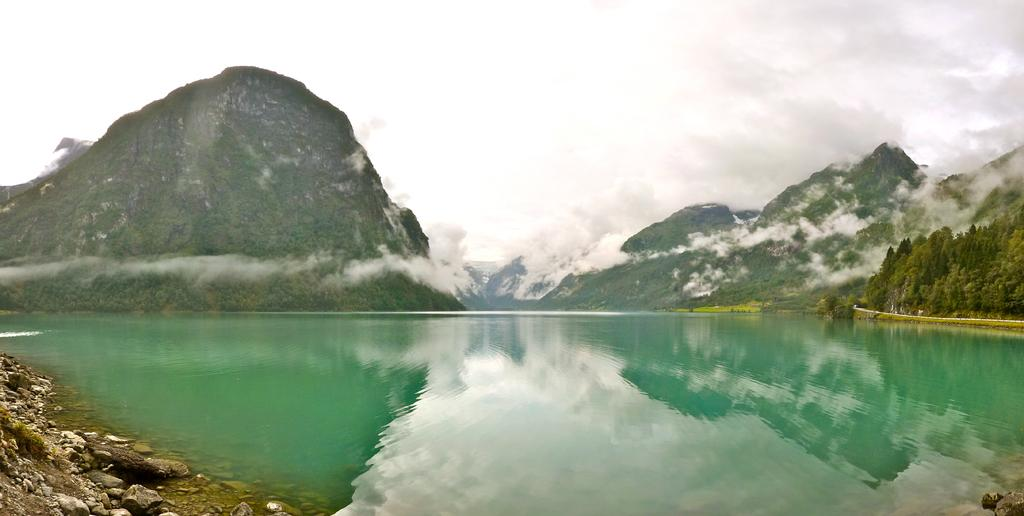What type of natural landform can be seen in the image? There are mountains in the image. What body of water is visible in the image? There is water visible in the image. What type of vegetation is present in the image? There are trees in the image. What atmospheric feature can be seen in the image? Clouds are present in the image. What type of weather condition is suggested by the presence of snow in the image? The presence of snow suggests cold weather in the image. What part of the environment is visible in the image? The sky is visible in the image. What is the name of the island in the image? There is no island present in the image; it features mountains, water, trees, clouds, and snow. How does the brake system work on the vehicle in the image? There is no vehicle present in the image, so it is not possible to discuss the brake system. 